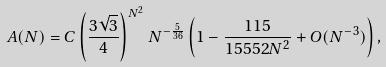<formula> <loc_0><loc_0><loc_500><loc_500>A ( N ) = C \left ( \frac { 3 \sqrt { 3 } } { 4 } \right ) ^ { N ^ { 2 } } N ^ { - \frac { 5 } { 3 6 } } \left ( 1 - \frac { 1 1 5 } { 1 5 5 5 2 N ^ { 2 } } + O ( N ^ { - 3 } ) \right ) ,</formula> 